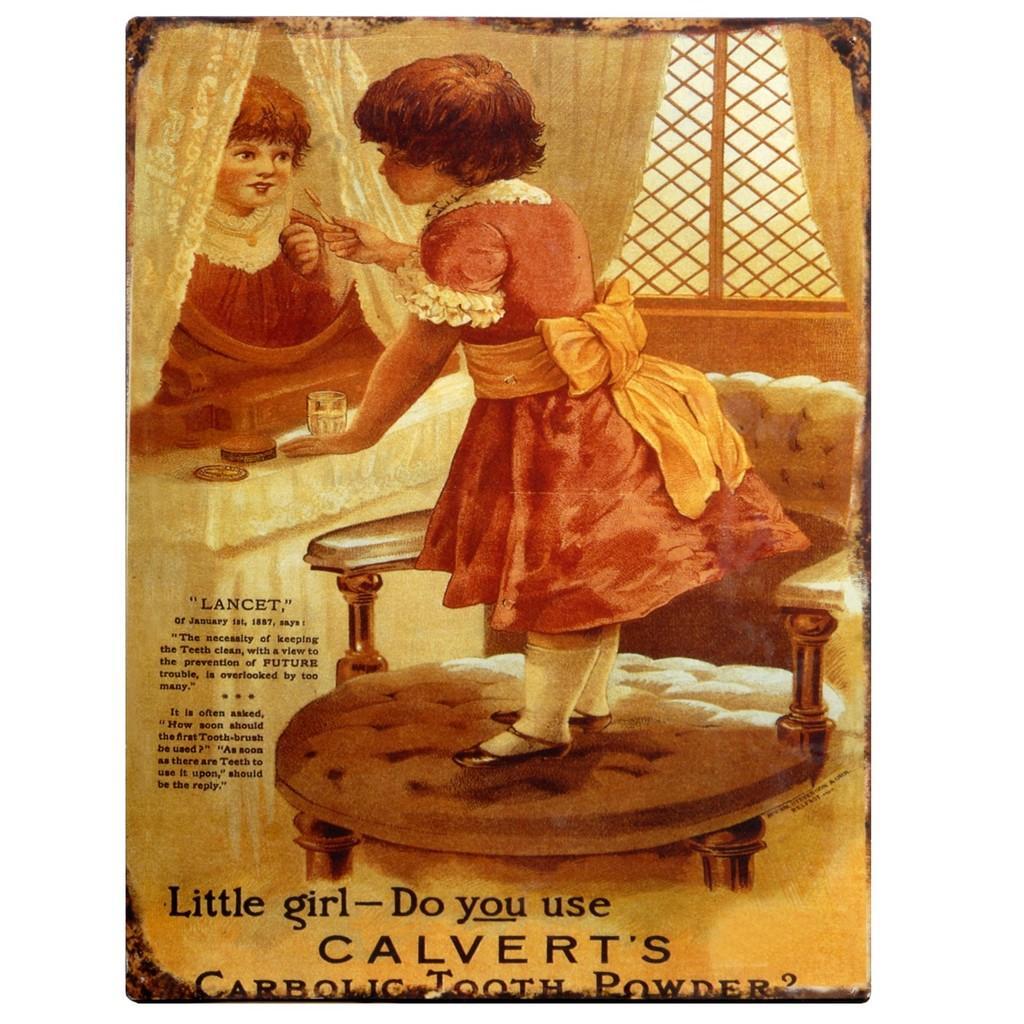Please provide a concise description of this image. In this picture I can see a poster on which a girl standing on the chair in front of the mirror and holding a brash, we can see some text on the poster. 